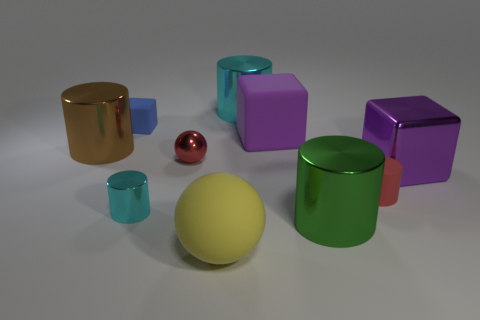Subtract all red cylinders. Subtract all brown spheres. How many cylinders are left? 4 Subtract all balls. How many objects are left? 8 Subtract 0 gray balls. How many objects are left? 10 Subtract all big brown rubber blocks. Subtract all metallic cylinders. How many objects are left? 6 Add 5 green cylinders. How many green cylinders are left? 6 Add 5 tiny cubes. How many tiny cubes exist? 6 